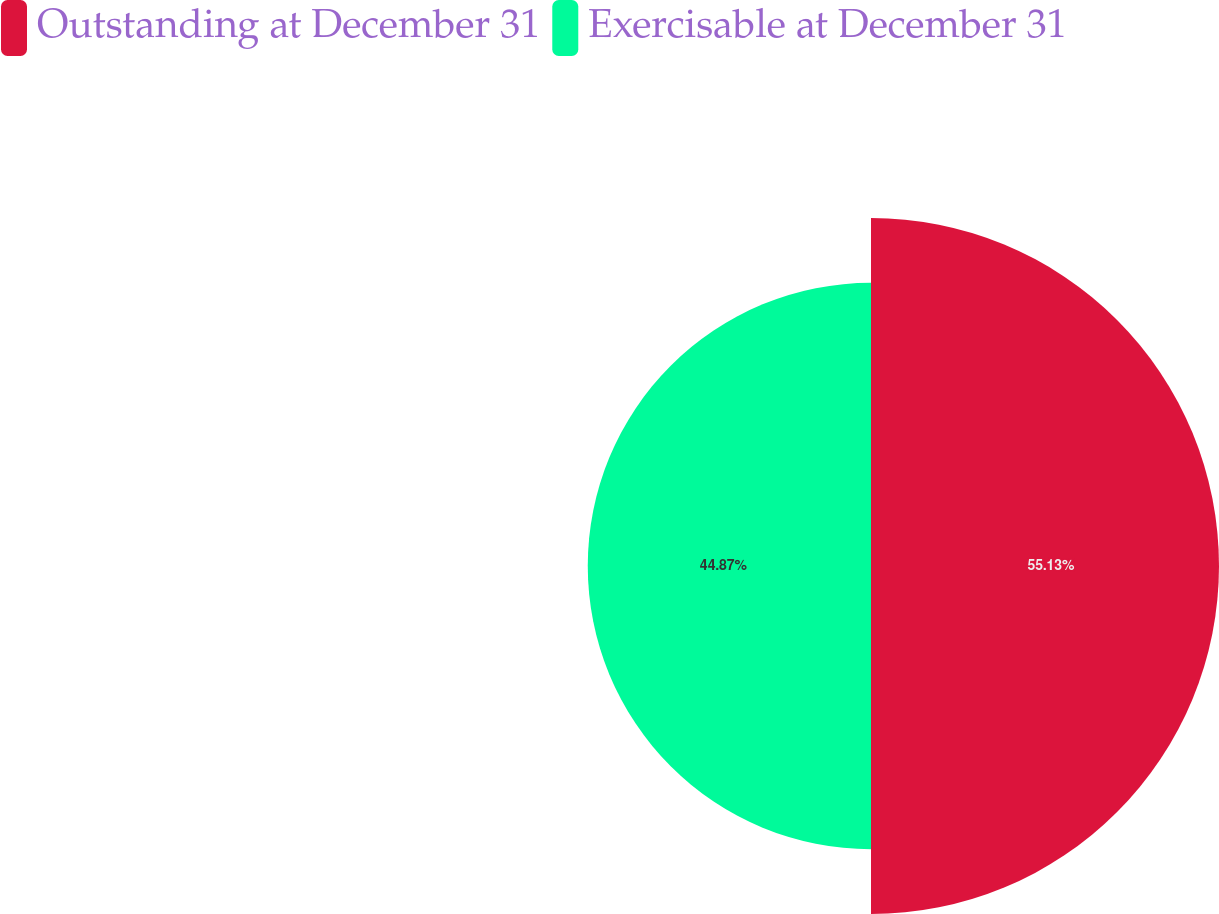<chart> <loc_0><loc_0><loc_500><loc_500><pie_chart><fcel>Outstanding at December 31<fcel>Exercisable at December 31<nl><fcel>55.13%<fcel>44.87%<nl></chart> 